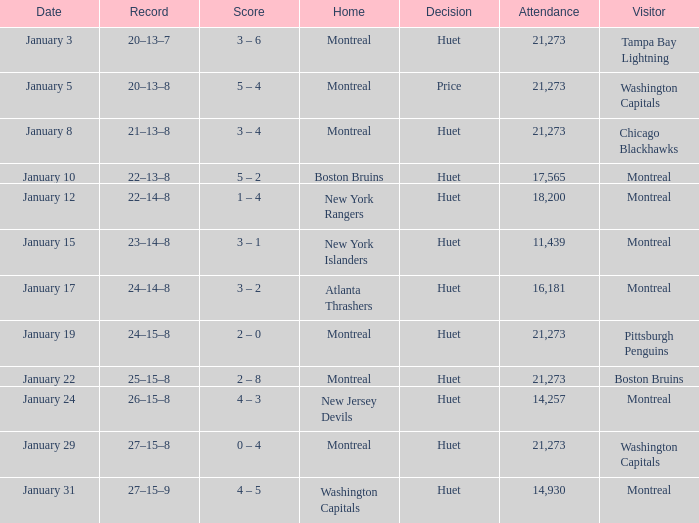What was the score of the game when the Boston Bruins were the visiting team? 2 – 8. 